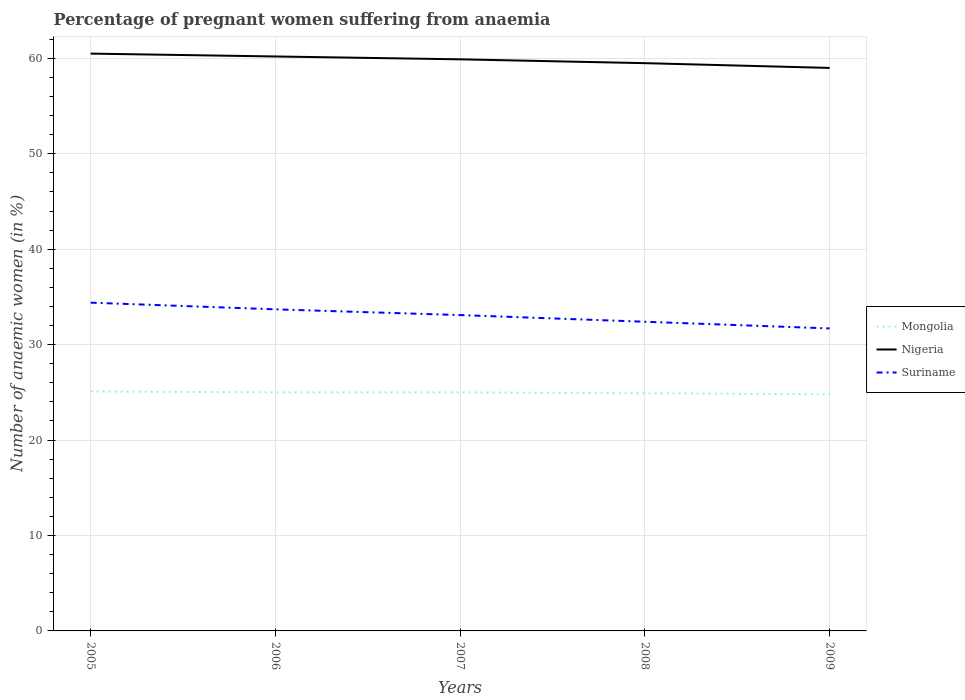How many different coloured lines are there?
Your answer should be very brief. 3. Is the number of lines equal to the number of legend labels?
Make the answer very short. Yes. Across all years, what is the maximum number of anaemic women in Mongolia?
Make the answer very short. 24.8. What is the total number of anaemic women in Suriname in the graph?
Provide a succinct answer. 0.7. What is the difference between the highest and the second highest number of anaemic women in Mongolia?
Keep it short and to the point. 0.3. What is the difference between the highest and the lowest number of anaemic women in Mongolia?
Provide a short and direct response. 3. Is the number of anaemic women in Nigeria strictly greater than the number of anaemic women in Suriname over the years?
Give a very brief answer. No. How many years are there in the graph?
Ensure brevity in your answer.  5. What is the difference between two consecutive major ticks on the Y-axis?
Offer a very short reply. 10. Are the values on the major ticks of Y-axis written in scientific E-notation?
Provide a succinct answer. No. Where does the legend appear in the graph?
Provide a short and direct response. Center right. How many legend labels are there?
Offer a terse response. 3. How are the legend labels stacked?
Ensure brevity in your answer.  Vertical. What is the title of the graph?
Your answer should be very brief. Percentage of pregnant women suffering from anaemia. What is the label or title of the X-axis?
Offer a very short reply. Years. What is the label or title of the Y-axis?
Offer a very short reply. Number of anaemic women (in %). What is the Number of anaemic women (in %) in Mongolia in 2005?
Ensure brevity in your answer.  25.1. What is the Number of anaemic women (in %) in Nigeria in 2005?
Your response must be concise. 60.5. What is the Number of anaemic women (in %) in Suriname in 2005?
Ensure brevity in your answer.  34.4. What is the Number of anaemic women (in %) in Mongolia in 2006?
Your answer should be very brief. 25. What is the Number of anaemic women (in %) in Nigeria in 2006?
Offer a very short reply. 60.2. What is the Number of anaemic women (in %) in Suriname in 2006?
Give a very brief answer. 33.7. What is the Number of anaemic women (in %) in Nigeria in 2007?
Offer a very short reply. 59.9. What is the Number of anaemic women (in %) in Suriname in 2007?
Offer a terse response. 33.1. What is the Number of anaemic women (in %) of Mongolia in 2008?
Give a very brief answer. 24.9. What is the Number of anaemic women (in %) of Nigeria in 2008?
Offer a very short reply. 59.5. What is the Number of anaemic women (in %) in Suriname in 2008?
Your answer should be very brief. 32.4. What is the Number of anaemic women (in %) in Mongolia in 2009?
Make the answer very short. 24.8. What is the Number of anaemic women (in %) in Nigeria in 2009?
Provide a succinct answer. 59. What is the Number of anaemic women (in %) in Suriname in 2009?
Your answer should be very brief. 31.7. Across all years, what is the maximum Number of anaemic women (in %) in Mongolia?
Keep it short and to the point. 25.1. Across all years, what is the maximum Number of anaemic women (in %) in Nigeria?
Offer a very short reply. 60.5. Across all years, what is the maximum Number of anaemic women (in %) of Suriname?
Keep it short and to the point. 34.4. Across all years, what is the minimum Number of anaemic women (in %) in Mongolia?
Your answer should be compact. 24.8. Across all years, what is the minimum Number of anaemic women (in %) of Suriname?
Your response must be concise. 31.7. What is the total Number of anaemic women (in %) of Mongolia in the graph?
Offer a very short reply. 124.8. What is the total Number of anaemic women (in %) in Nigeria in the graph?
Offer a terse response. 299.1. What is the total Number of anaemic women (in %) of Suriname in the graph?
Offer a terse response. 165.3. What is the difference between the Number of anaemic women (in %) in Mongolia in 2005 and that in 2006?
Ensure brevity in your answer.  0.1. What is the difference between the Number of anaemic women (in %) in Suriname in 2005 and that in 2006?
Offer a terse response. 0.7. What is the difference between the Number of anaemic women (in %) in Mongolia in 2005 and that in 2008?
Your answer should be very brief. 0.2. What is the difference between the Number of anaemic women (in %) in Nigeria in 2005 and that in 2008?
Give a very brief answer. 1. What is the difference between the Number of anaemic women (in %) of Nigeria in 2005 and that in 2009?
Make the answer very short. 1.5. What is the difference between the Number of anaemic women (in %) in Suriname in 2005 and that in 2009?
Make the answer very short. 2.7. What is the difference between the Number of anaemic women (in %) in Mongolia in 2006 and that in 2007?
Offer a very short reply. 0. What is the difference between the Number of anaemic women (in %) in Nigeria in 2006 and that in 2007?
Give a very brief answer. 0.3. What is the difference between the Number of anaemic women (in %) in Mongolia in 2006 and that in 2008?
Offer a very short reply. 0.1. What is the difference between the Number of anaemic women (in %) in Nigeria in 2007 and that in 2008?
Offer a terse response. 0.4. What is the difference between the Number of anaemic women (in %) of Suriname in 2007 and that in 2008?
Your response must be concise. 0.7. What is the difference between the Number of anaemic women (in %) of Mongolia in 2007 and that in 2009?
Your answer should be compact. 0.2. What is the difference between the Number of anaemic women (in %) in Nigeria in 2007 and that in 2009?
Your answer should be compact. 0.9. What is the difference between the Number of anaemic women (in %) in Mongolia in 2008 and that in 2009?
Keep it short and to the point. 0.1. What is the difference between the Number of anaemic women (in %) in Nigeria in 2008 and that in 2009?
Provide a succinct answer. 0.5. What is the difference between the Number of anaemic women (in %) of Mongolia in 2005 and the Number of anaemic women (in %) of Nigeria in 2006?
Offer a very short reply. -35.1. What is the difference between the Number of anaemic women (in %) of Nigeria in 2005 and the Number of anaemic women (in %) of Suriname in 2006?
Give a very brief answer. 26.8. What is the difference between the Number of anaemic women (in %) of Mongolia in 2005 and the Number of anaemic women (in %) of Nigeria in 2007?
Provide a short and direct response. -34.8. What is the difference between the Number of anaemic women (in %) in Nigeria in 2005 and the Number of anaemic women (in %) in Suriname in 2007?
Offer a very short reply. 27.4. What is the difference between the Number of anaemic women (in %) in Mongolia in 2005 and the Number of anaemic women (in %) in Nigeria in 2008?
Offer a terse response. -34.4. What is the difference between the Number of anaemic women (in %) in Mongolia in 2005 and the Number of anaemic women (in %) in Suriname in 2008?
Offer a terse response. -7.3. What is the difference between the Number of anaemic women (in %) of Nigeria in 2005 and the Number of anaemic women (in %) of Suriname in 2008?
Your response must be concise. 28.1. What is the difference between the Number of anaemic women (in %) of Mongolia in 2005 and the Number of anaemic women (in %) of Nigeria in 2009?
Your answer should be compact. -33.9. What is the difference between the Number of anaemic women (in %) of Mongolia in 2005 and the Number of anaemic women (in %) of Suriname in 2009?
Make the answer very short. -6.6. What is the difference between the Number of anaemic women (in %) in Nigeria in 2005 and the Number of anaemic women (in %) in Suriname in 2009?
Your answer should be very brief. 28.8. What is the difference between the Number of anaemic women (in %) of Mongolia in 2006 and the Number of anaemic women (in %) of Nigeria in 2007?
Your response must be concise. -34.9. What is the difference between the Number of anaemic women (in %) of Nigeria in 2006 and the Number of anaemic women (in %) of Suriname in 2007?
Your answer should be compact. 27.1. What is the difference between the Number of anaemic women (in %) in Mongolia in 2006 and the Number of anaemic women (in %) in Nigeria in 2008?
Give a very brief answer. -34.5. What is the difference between the Number of anaemic women (in %) in Mongolia in 2006 and the Number of anaemic women (in %) in Suriname in 2008?
Your answer should be compact. -7.4. What is the difference between the Number of anaemic women (in %) in Nigeria in 2006 and the Number of anaemic women (in %) in Suriname in 2008?
Ensure brevity in your answer.  27.8. What is the difference between the Number of anaemic women (in %) in Mongolia in 2006 and the Number of anaemic women (in %) in Nigeria in 2009?
Your answer should be very brief. -34. What is the difference between the Number of anaemic women (in %) in Nigeria in 2006 and the Number of anaemic women (in %) in Suriname in 2009?
Your answer should be compact. 28.5. What is the difference between the Number of anaemic women (in %) of Mongolia in 2007 and the Number of anaemic women (in %) of Nigeria in 2008?
Provide a short and direct response. -34.5. What is the difference between the Number of anaemic women (in %) in Mongolia in 2007 and the Number of anaemic women (in %) in Suriname in 2008?
Offer a terse response. -7.4. What is the difference between the Number of anaemic women (in %) of Nigeria in 2007 and the Number of anaemic women (in %) of Suriname in 2008?
Your answer should be very brief. 27.5. What is the difference between the Number of anaemic women (in %) of Mongolia in 2007 and the Number of anaemic women (in %) of Nigeria in 2009?
Provide a succinct answer. -34. What is the difference between the Number of anaemic women (in %) in Nigeria in 2007 and the Number of anaemic women (in %) in Suriname in 2009?
Provide a short and direct response. 28.2. What is the difference between the Number of anaemic women (in %) of Mongolia in 2008 and the Number of anaemic women (in %) of Nigeria in 2009?
Keep it short and to the point. -34.1. What is the difference between the Number of anaemic women (in %) in Nigeria in 2008 and the Number of anaemic women (in %) in Suriname in 2009?
Give a very brief answer. 27.8. What is the average Number of anaemic women (in %) in Mongolia per year?
Provide a short and direct response. 24.96. What is the average Number of anaemic women (in %) of Nigeria per year?
Give a very brief answer. 59.82. What is the average Number of anaemic women (in %) in Suriname per year?
Provide a short and direct response. 33.06. In the year 2005, what is the difference between the Number of anaemic women (in %) of Mongolia and Number of anaemic women (in %) of Nigeria?
Your response must be concise. -35.4. In the year 2005, what is the difference between the Number of anaemic women (in %) of Nigeria and Number of anaemic women (in %) of Suriname?
Your answer should be very brief. 26.1. In the year 2006, what is the difference between the Number of anaemic women (in %) in Mongolia and Number of anaemic women (in %) in Nigeria?
Offer a very short reply. -35.2. In the year 2006, what is the difference between the Number of anaemic women (in %) in Mongolia and Number of anaemic women (in %) in Suriname?
Offer a very short reply. -8.7. In the year 2006, what is the difference between the Number of anaemic women (in %) in Nigeria and Number of anaemic women (in %) in Suriname?
Your answer should be compact. 26.5. In the year 2007, what is the difference between the Number of anaemic women (in %) in Mongolia and Number of anaemic women (in %) in Nigeria?
Provide a succinct answer. -34.9. In the year 2007, what is the difference between the Number of anaemic women (in %) in Nigeria and Number of anaemic women (in %) in Suriname?
Offer a terse response. 26.8. In the year 2008, what is the difference between the Number of anaemic women (in %) of Mongolia and Number of anaemic women (in %) of Nigeria?
Your answer should be compact. -34.6. In the year 2008, what is the difference between the Number of anaemic women (in %) of Nigeria and Number of anaemic women (in %) of Suriname?
Offer a terse response. 27.1. In the year 2009, what is the difference between the Number of anaemic women (in %) of Mongolia and Number of anaemic women (in %) of Nigeria?
Give a very brief answer. -34.2. In the year 2009, what is the difference between the Number of anaemic women (in %) of Mongolia and Number of anaemic women (in %) of Suriname?
Your answer should be compact. -6.9. In the year 2009, what is the difference between the Number of anaemic women (in %) in Nigeria and Number of anaemic women (in %) in Suriname?
Keep it short and to the point. 27.3. What is the ratio of the Number of anaemic women (in %) in Suriname in 2005 to that in 2006?
Give a very brief answer. 1.02. What is the ratio of the Number of anaemic women (in %) in Suriname in 2005 to that in 2007?
Provide a short and direct response. 1.04. What is the ratio of the Number of anaemic women (in %) of Nigeria in 2005 to that in 2008?
Give a very brief answer. 1.02. What is the ratio of the Number of anaemic women (in %) of Suriname in 2005 to that in 2008?
Make the answer very short. 1.06. What is the ratio of the Number of anaemic women (in %) in Mongolia in 2005 to that in 2009?
Ensure brevity in your answer.  1.01. What is the ratio of the Number of anaemic women (in %) of Nigeria in 2005 to that in 2009?
Keep it short and to the point. 1.03. What is the ratio of the Number of anaemic women (in %) in Suriname in 2005 to that in 2009?
Your answer should be compact. 1.09. What is the ratio of the Number of anaemic women (in %) of Suriname in 2006 to that in 2007?
Your response must be concise. 1.02. What is the ratio of the Number of anaemic women (in %) in Nigeria in 2006 to that in 2008?
Keep it short and to the point. 1.01. What is the ratio of the Number of anaemic women (in %) of Suriname in 2006 to that in 2008?
Give a very brief answer. 1.04. What is the ratio of the Number of anaemic women (in %) in Mongolia in 2006 to that in 2009?
Your response must be concise. 1.01. What is the ratio of the Number of anaemic women (in %) in Nigeria in 2006 to that in 2009?
Make the answer very short. 1.02. What is the ratio of the Number of anaemic women (in %) in Suriname in 2006 to that in 2009?
Keep it short and to the point. 1.06. What is the ratio of the Number of anaemic women (in %) of Suriname in 2007 to that in 2008?
Your answer should be very brief. 1.02. What is the ratio of the Number of anaemic women (in %) in Mongolia in 2007 to that in 2009?
Your answer should be very brief. 1.01. What is the ratio of the Number of anaemic women (in %) in Nigeria in 2007 to that in 2009?
Offer a very short reply. 1.02. What is the ratio of the Number of anaemic women (in %) in Suriname in 2007 to that in 2009?
Offer a terse response. 1.04. What is the ratio of the Number of anaemic women (in %) of Mongolia in 2008 to that in 2009?
Keep it short and to the point. 1. What is the ratio of the Number of anaemic women (in %) of Nigeria in 2008 to that in 2009?
Ensure brevity in your answer.  1.01. What is the ratio of the Number of anaemic women (in %) in Suriname in 2008 to that in 2009?
Keep it short and to the point. 1.02. What is the difference between the highest and the second highest Number of anaemic women (in %) of Nigeria?
Give a very brief answer. 0.3. What is the difference between the highest and the second highest Number of anaemic women (in %) in Suriname?
Ensure brevity in your answer.  0.7. What is the difference between the highest and the lowest Number of anaemic women (in %) of Mongolia?
Ensure brevity in your answer.  0.3. What is the difference between the highest and the lowest Number of anaemic women (in %) in Nigeria?
Give a very brief answer. 1.5. What is the difference between the highest and the lowest Number of anaemic women (in %) in Suriname?
Ensure brevity in your answer.  2.7. 